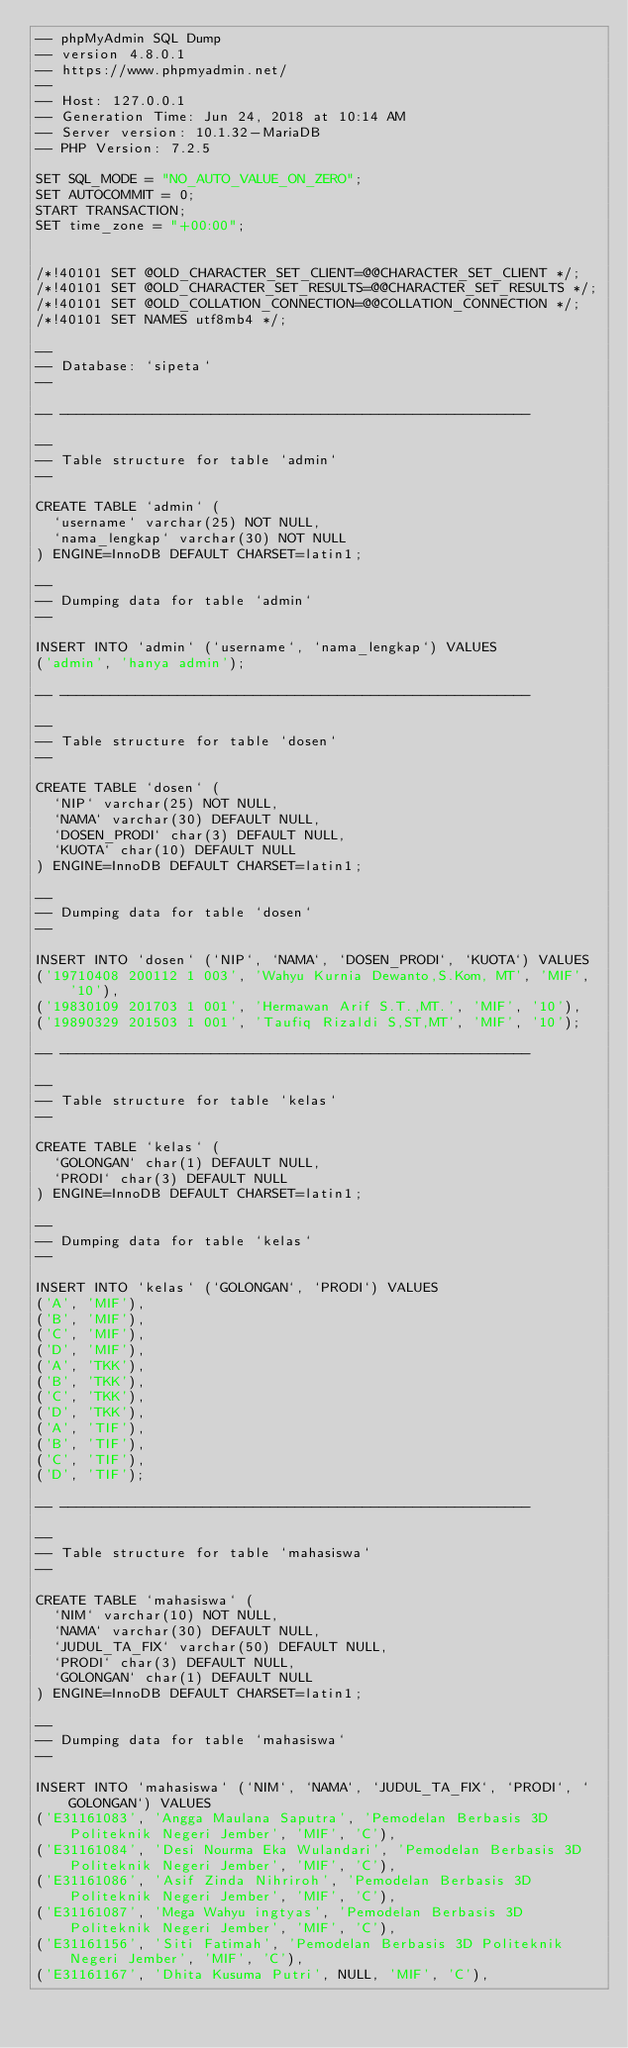<code> <loc_0><loc_0><loc_500><loc_500><_SQL_>-- phpMyAdmin SQL Dump
-- version 4.8.0.1
-- https://www.phpmyadmin.net/
--
-- Host: 127.0.0.1
-- Generation Time: Jun 24, 2018 at 10:14 AM
-- Server version: 10.1.32-MariaDB
-- PHP Version: 7.2.5

SET SQL_MODE = "NO_AUTO_VALUE_ON_ZERO";
SET AUTOCOMMIT = 0;
START TRANSACTION;
SET time_zone = "+00:00";


/*!40101 SET @OLD_CHARACTER_SET_CLIENT=@@CHARACTER_SET_CLIENT */;
/*!40101 SET @OLD_CHARACTER_SET_RESULTS=@@CHARACTER_SET_RESULTS */;
/*!40101 SET @OLD_COLLATION_CONNECTION=@@COLLATION_CONNECTION */;
/*!40101 SET NAMES utf8mb4 */;

--
-- Database: `sipeta`
--

-- --------------------------------------------------------

--
-- Table structure for table `admin`
--

CREATE TABLE `admin` (
  `username` varchar(25) NOT NULL,
  `nama_lengkap` varchar(30) NOT NULL
) ENGINE=InnoDB DEFAULT CHARSET=latin1;

--
-- Dumping data for table `admin`
--

INSERT INTO `admin` (`username`, `nama_lengkap`) VALUES
('admin', 'hanya admin');

-- --------------------------------------------------------

--
-- Table structure for table `dosen`
--

CREATE TABLE `dosen` (
  `NIP` varchar(25) NOT NULL,
  `NAMA` varchar(30) DEFAULT NULL,
  `DOSEN_PRODI` char(3) DEFAULT NULL,
  `KUOTA` char(10) DEFAULT NULL
) ENGINE=InnoDB DEFAULT CHARSET=latin1;

--
-- Dumping data for table `dosen`
--

INSERT INTO `dosen` (`NIP`, `NAMA`, `DOSEN_PRODI`, `KUOTA`) VALUES
('19710408 200112 1 003', 'Wahyu Kurnia Dewanto,S.Kom, MT', 'MIF', '10'),
('19830109 201703 1 001', 'Hermawan Arif S.T.,MT.', 'MIF', '10'),
('19890329 201503 1 001', 'Taufiq Rizaldi S,ST,MT', 'MIF', '10');

-- --------------------------------------------------------

--
-- Table structure for table `kelas`
--

CREATE TABLE `kelas` (
  `GOLONGAN` char(1) DEFAULT NULL,
  `PRODI` char(3) DEFAULT NULL
) ENGINE=InnoDB DEFAULT CHARSET=latin1;

--
-- Dumping data for table `kelas`
--

INSERT INTO `kelas` (`GOLONGAN`, `PRODI`) VALUES
('A', 'MIF'),
('B', 'MIF'),
('C', 'MIF'),
('D', 'MIF'),
('A', 'TKK'),
('B', 'TKK'),
('C', 'TKK'),
('D', 'TKK'),
('A', 'TIF'),
('B', 'TIF'),
('C', 'TIF'),
('D', 'TIF');

-- --------------------------------------------------------

--
-- Table structure for table `mahasiswa`
--

CREATE TABLE `mahasiswa` (
  `NIM` varchar(10) NOT NULL,
  `NAMA` varchar(30) DEFAULT NULL,
  `JUDUL_TA_FIX` varchar(50) DEFAULT NULL,
  `PRODI` char(3) DEFAULT NULL,
  `GOLONGAN` char(1) DEFAULT NULL
) ENGINE=InnoDB DEFAULT CHARSET=latin1;

--
-- Dumping data for table `mahasiswa`
--

INSERT INTO `mahasiswa` (`NIM`, `NAMA`, `JUDUL_TA_FIX`, `PRODI`, `GOLONGAN`) VALUES
('E31161083', 'Angga Maulana Saputra', 'Pemodelan Berbasis 3D Politeknik Negeri Jember', 'MIF', 'C'),
('E31161084', 'Desi Nourma Eka Wulandari', 'Pemodelan Berbasis 3D Politeknik Negeri Jember', 'MIF', 'C'),
('E31161086', 'Asif Zinda Nihriroh', 'Pemodelan Berbasis 3D Politeknik Negeri Jember', 'MIF', 'C'),
('E31161087', 'Mega Wahyu ingtyas', 'Pemodelan Berbasis 3D Politeknik Negeri Jember', 'MIF', 'C'),
('E31161156', 'Siti Fatimah', 'Pemodelan Berbasis 3D Politeknik Negeri Jember', 'MIF', 'C'),
('E31161167', 'Dhita Kusuma Putri', NULL, 'MIF', 'C'),</code> 